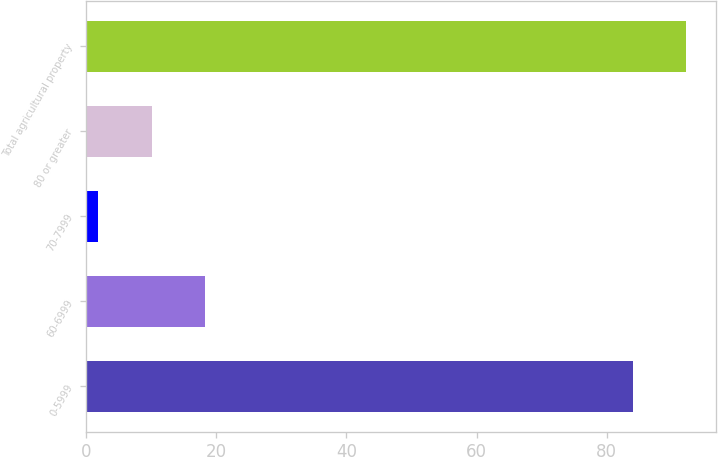Convert chart. <chart><loc_0><loc_0><loc_500><loc_500><bar_chart><fcel>0-5999<fcel>60-6999<fcel>70-7999<fcel>80 or greater<fcel>Total agricultural property<nl><fcel>84<fcel>18.26<fcel>1.82<fcel>10.04<fcel>92.22<nl></chart> 